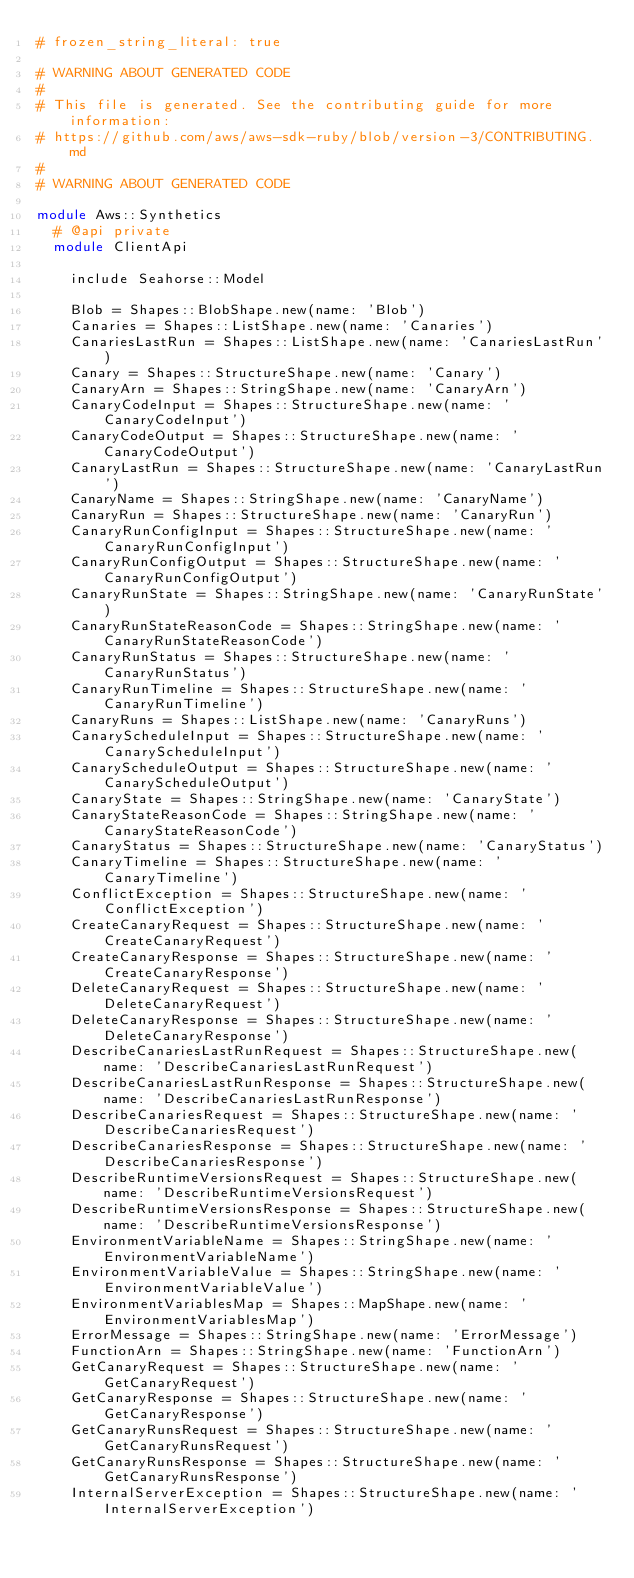Convert code to text. <code><loc_0><loc_0><loc_500><loc_500><_Ruby_># frozen_string_literal: true

# WARNING ABOUT GENERATED CODE
#
# This file is generated. See the contributing guide for more information:
# https://github.com/aws/aws-sdk-ruby/blob/version-3/CONTRIBUTING.md
#
# WARNING ABOUT GENERATED CODE

module Aws::Synthetics
  # @api private
  module ClientApi

    include Seahorse::Model

    Blob = Shapes::BlobShape.new(name: 'Blob')
    Canaries = Shapes::ListShape.new(name: 'Canaries')
    CanariesLastRun = Shapes::ListShape.new(name: 'CanariesLastRun')
    Canary = Shapes::StructureShape.new(name: 'Canary')
    CanaryArn = Shapes::StringShape.new(name: 'CanaryArn')
    CanaryCodeInput = Shapes::StructureShape.new(name: 'CanaryCodeInput')
    CanaryCodeOutput = Shapes::StructureShape.new(name: 'CanaryCodeOutput')
    CanaryLastRun = Shapes::StructureShape.new(name: 'CanaryLastRun')
    CanaryName = Shapes::StringShape.new(name: 'CanaryName')
    CanaryRun = Shapes::StructureShape.new(name: 'CanaryRun')
    CanaryRunConfigInput = Shapes::StructureShape.new(name: 'CanaryRunConfigInput')
    CanaryRunConfigOutput = Shapes::StructureShape.new(name: 'CanaryRunConfigOutput')
    CanaryRunState = Shapes::StringShape.new(name: 'CanaryRunState')
    CanaryRunStateReasonCode = Shapes::StringShape.new(name: 'CanaryRunStateReasonCode')
    CanaryRunStatus = Shapes::StructureShape.new(name: 'CanaryRunStatus')
    CanaryRunTimeline = Shapes::StructureShape.new(name: 'CanaryRunTimeline')
    CanaryRuns = Shapes::ListShape.new(name: 'CanaryRuns')
    CanaryScheduleInput = Shapes::StructureShape.new(name: 'CanaryScheduleInput')
    CanaryScheduleOutput = Shapes::StructureShape.new(name: 'CanaryScheduleOutput')
    CanaryState = Shapes::StringShape.new(name: 'CanaryState')
    CanaryStateReasonCode = Shapes::StringShape.new(name: 'CanaryStateReasonCode')
    CanaryStatus = Shapes::StructureShape.new(name: 'CanaryStatus')
    CanaryTimeline = Shapes::StructureShape.new(name: 'CanaryTimeline')
    ConflictException = Shapes::StructureShape.new(name: 'ConflictException')
    CreateCanaryRequest = Shapes::StructureShape.new(name: 'CreateCanaryRequest')
    CreateCanaryResponse = Shapes::StructureShape.new(name: 'CreateCanaryResponse')
    DeleteCanaryRequest = Shapes::StructureShape.new(name: 'DeleteCanaryRequest')
    DeleteCanaryResponse = Shapes::StructureShape.new(name: 'DeleteCanaryResponse')
    DescribeCanariesLastRunRequest = Shapes::StructureShape.new(name: 'DescribeCanariesLastRunRequest')
    DescribeCanariesLastRunResponse = Shapes::StructureShape.new(name: 'DescribeCanariesLastRunResponse')
    DescribeCanariesRequest = Shapes::StructureShape.new(name: 'DescribeCanariesRequest')
    DescribeCanariesResponse = Shapes::StructureShape.new(name: 'DescribeCanariesResponse')
    DescribeRuntimeVersionsRequest = Shapes::StructureShape.new(name: 'DescribeRuntimeVersionsRequest')
    DescribeRuntimeVersionsResponse = Shapes::StructureShape.new(name: 'DescribeRuntimeVersionsResponse')
    EnvironmentVariableName = Shapes::StringShape.new(name: 'EnvironmentVariableName')
    EnvironmentVariableValue = Shapes::StringShape.new(name: 'EnvironmentVariableValue')
    EnvironmentVariablesMap = Shapes::MapShape.new(name: 'EnvironmentVariablesMap')
    ErrorMessage = Shapes::StringShape.new(name: 'ErrorMessage')
    FunctionArn = Shapes::StringShape.new(name: 'FunctionArn')
    GetCanaryRequest = Shapes::StructureShape.new(name: 'GetCanaryRequest')
    GetCanaryResponse = Shapes::StructureShape.new(name: 'GetCanaryResponse')
    GetCanaryRunsRequest = Shapes::StructureShape.new(name: 'GetCanaryRunsRequest')
    GetCanaryRunsResponse = Shapes::StructureShape.new(name: 'GetCanaryRunsResponse')
    InternalServerException = Shapes::StructureShape.new(name: 'InternalServerException')</code> 